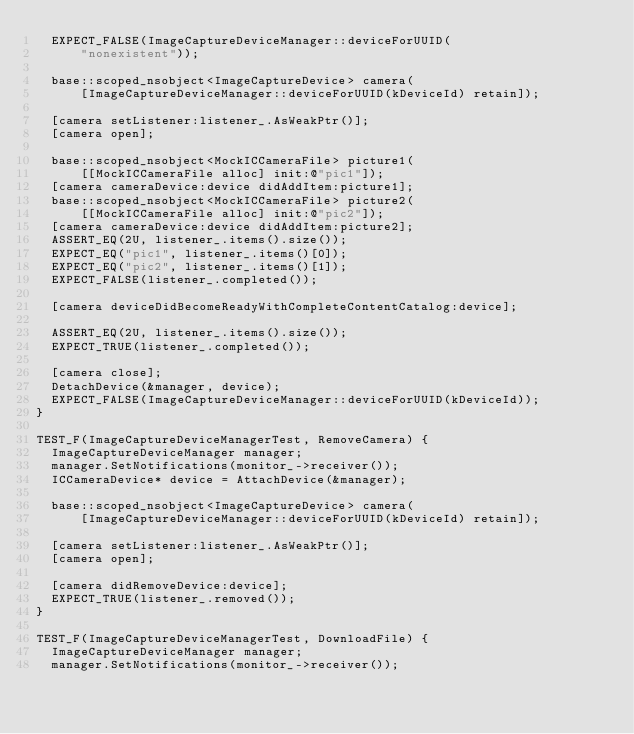<code> <loc_0><loc_0><loc_500><loc_500><_ObjectiveC_>  EXPECT_FALSE(ImageCaptureDeviceManager::deviceForUUID(
      "nonexistent"));

  base::scoped_nsobject<ImageCaptureDevice> camera(
      [ImageCaptureDeviceManager::deviceForUUID(kDeviceId) retain]);

  [camera setListener:listener_.AsWeakPtr()];
  [camera open];

  base::scoped_nsobject<MockICCameraFile> picture1(
      [[MockICCameraFile alloc] init:@"pic1"]);
  [camera cameraDevice:device didAddItem:picture1];
  base::scoped_nsobject<MockICCameraFile> picture2(
      [[MockICCameraFile alloc] init:@"pic2"]);
  [camera cameraDevice:device didAddItem:picture2];
  ASSERT_EQ(2U, listener_.items().size());
  EXPECT_EQ("pic1", listener_.items()[0]);
  EXPECT_EQ("pic2", listener_.items()[1]);
  EXPECT_FALSE(listener_.completed());

  [camera deviceDidBecomeReadyWithCompleteContentCatalog:device];

  ASSERT_EQ(2U, listener_.items().size());
  EXPECT_TRUE(listener_.completed());

  [camera close];
  DetachDevice(&manager, device);
  EXPECT_FALSE(ImageCaptureDeviceManager::deviceForUUID(kDeviceId));
}

TEST_F(ImageCaptureDeviceManagerTest, RemoveCamera) {
  ImageCaptureDeviceManager manager;
  manager.SetNotifications(monitor_->receiver());
  ICCameraDevice* device = AttachDevice(&manager);

  base::scoped_nsobject<ImageCaptureDevice> camera(
      [ImageCaptureDeviceManager::deviceForUUID(kDeviceId) retain]);

  [camera setListener:listener_.AsWeakPtr()];
  [camera open];

  [camera didRemoveDevice:device];
  EXPECT_TRUE(listener_.removed());
}

TEST_F(ImageCaptureDeviceManagerTest, DownloadFile) {
  ImageCaptureDeviceManager manager;
  manager.SetNotifications(monitor_->receiver());</code> 